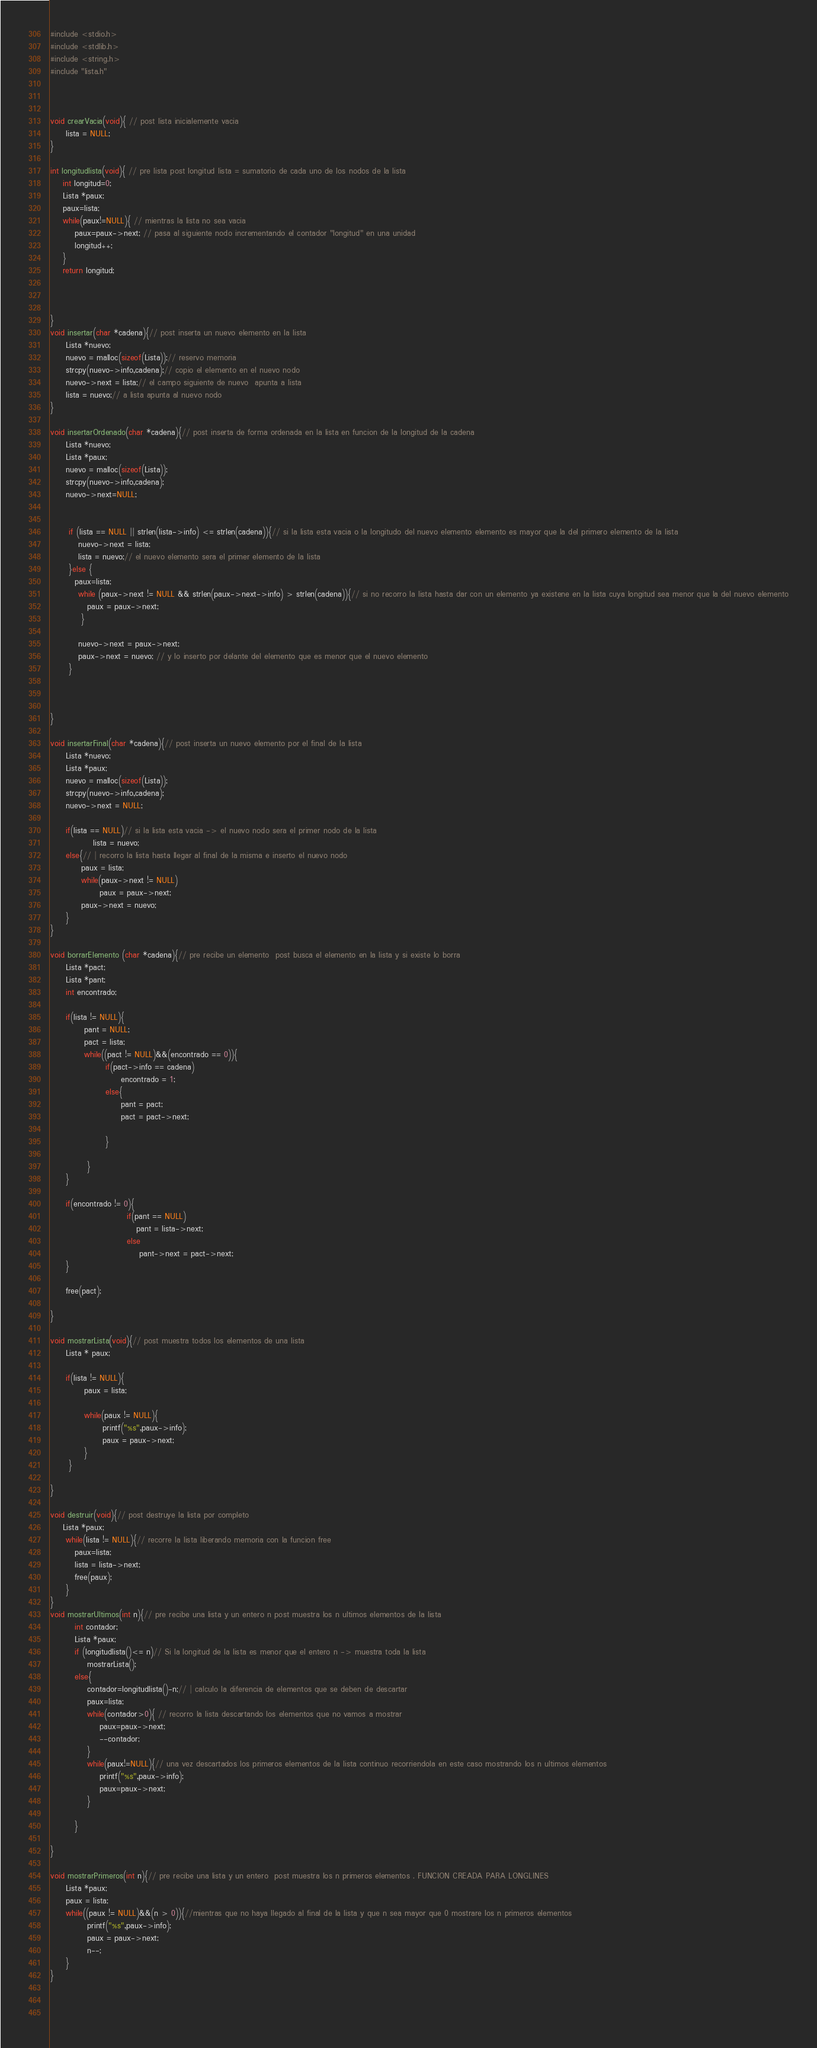<code> <loc_0><loc_0><loc_500><loc_500><_C_>#include <stdio.h>
#include <stdlib.h>
#include <string.h>
#include "lista.h"



void crearVacia(void){ // post lista inicialemente vacia 
	 lista = NULL;
}

int longitudlista(void){ // pre lista post longitud lista = sumatorio de cada uno de los nodos de la lista
	int longitud=0;
	Lista *paux;
	paux=lista;
	while(paux!=NULL){ // mientras la lista no sea vacia 
		paux=paux->next; // pasa al siguiente nodo incrementando el contador "longitud" en una unidad
		longitud++;
	}
	return longitud;
	
	
	
}
void insertar(char *cadena){// post inserta un nuevo elemento en la lista
	 Lista *nuevo;
	 nuevo = malloc(sizeof(Lista));// reservo memoria
	 strcpy(nuevo->info,cadena);// copio el elemento en el nuevo nodo
	 nuevo->next = lista;// el campo siguiente de nuevo  apunta a lista
	 lista = nuevo;// a lista apunta al nuevo nodo
}

void insertarOrdenado(char *cadena){// post inserta de forma ordenada en la lista en funcion de la longitud de la cadena
	 Lista *nuevo;
	 Lista *paux;
	 nuevo = malloc(sizeof(Lista));
	 strcpy(nuevo->info,cadena);
	 nuevo->next=NULL;
	
 
      if (lista == NULL || strlen(lista->info) <= strlen(cadena)){// si la lista esta vacia o la longitudo del nuevo elemento elemento es mayor que la del primero elemento de la lista 
         nuevo->next = lista; 
         lista = nuevo;// el nuevo elemento sera el primer elemento de la lista
      }else {
		paux=lista;
         while (paux->next != NULL && strlen(paux->next->info) > strlen(cadena)){// si no recorro la lista hasta dar con un elemento ya existene en la lista cuya longitud sea menor que la del nuevo elemento
            paux = paux->next;
          }
 
         nuevo->next = paux->next;
         paux->next = nuevo; // y lo inserto por delante del elemento que es menor que el nuevo elemento 
      }
		
	 

}

void insertarFinal(char *cadena){// post inserta un nuevo elemento por el final de la lista 
	 Lista *nuevo;
	 Lista *paux;
	 nuevo = malloc(sizeof(Lista));
	 strcpy(nuevo->info,cadena);
	 nuevo->next = NULL;
	 
	 if(lista == NULL)// si la lista esta vacia -> el nuevo nodo sera el primer nodo de la lista
	          lista = nuevo;
	 else{// | recorro la lista hasta llegar al final de la misma e inserto el nuevo nodo
		  paux = lista;
		  while(paux->next != NULL)
		        paux = paux->next;
		  paux->next = nuevo;
	 }
}
		  
void borrarElemento (char *cadena){// pre recibe un elemento  post busca el elemento en la lista y si existe lo borra
	 Lista *pact;
	 Lista *pant;
	 int encontrado;
	 
	 if(lista != NULL){
		   pant = NULL;
		   pact = lista;
		   while((pact != NULL)&&(encontrado == 0)){
	              if(pact->info == cadena)
					   encontrado = 1;
				  else{
				       pant = pact; 
				       pact = pact->next;
				       
		          }
		   
            }
     }
       
     if(encontrado != 0){
		                 if(pant == NULL)
		                    pant = lista->next;
		                 else
		                     pant->next = pact->next;
     }
     
     free(pact);
     	        
} 	      
		    
void mostrarLista(void){// post muestra todos los elementos de una lista
	 Lista * paux;
	 
	 if(lista != NULL){
		   paux = lista;
		   
		   while(paux != NULL){
			     printf("%s",paux->info);
			     paux = paux->next;
		   }
      }
     
}

void destruir(void){// post destruye la lista por completo
	Lista *paux;
	 while(lista != NULL){// recorre la lista liberando memoria con la funcion free 
		paux=lista;
		lista = lista->next;
		free(paux);
	 }
}
void mostrarUltimos(int n){// pre recibe una lista y un entero n post muestra los n ultimos elementos de la lista 
		int contador;
		Lista *paux;
		if (longitudlista()<= n)// Si la longitud de la lista es menor que el entero n -> muestra toda la lista 
			mostrarLista();
		else{
			contador=longitudlista()-n;// | calculo la diferencia de elementos que se deben de descartar 
			paux=lista;
			while(contador>0){ // recorro la lista descartando los elementos que no vamos a mostrar
				paux=paux->next;
				--contador;
			}
			while(paux!=NULL){// una vez descartados los primeros elementos de la lista continuo recorriendola en este caso mostrando los n ultimos elementos
				printf("%s",paux->info);
				paux=paux->next;
			}
			
		}
	
}

void mostrarPrimeros(int n){// pre recibe una lista y un entero  post muestra los n primeros elementos . FUNCION CREADA PARA LONGLINES
	 Lista *paux;
	 paux = lista;
	 while((paux != NULL)&&(n > 0)){//mientras que no haya llegado al final de la lista y que n sea mayor que 0 mostrare los n primeros elementos
		    printf("%s",paux->info);
		    paux = paux->next;
		    n--;
     }
}


	  
</code> 